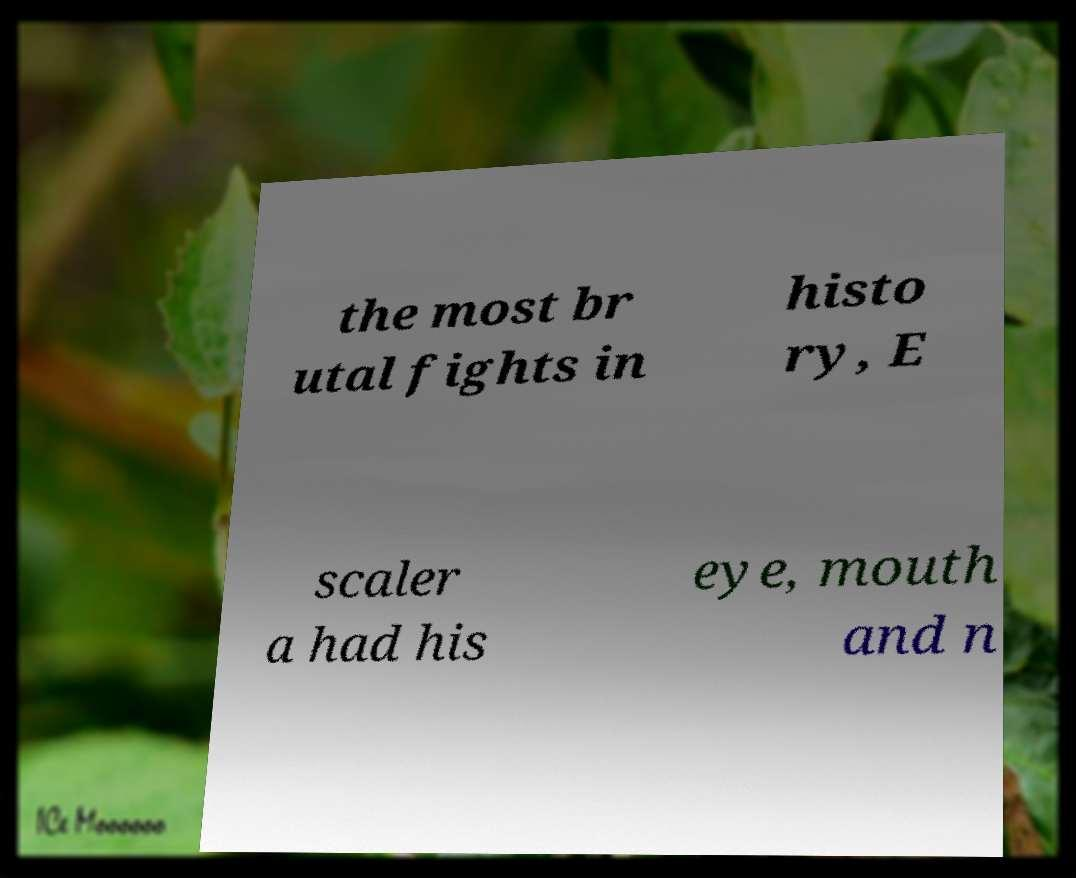Could you assist in decoding the text presented in this image and type it out clearly? the most br utal fights in histo ry, E scaler a had his eye, mouth and n 